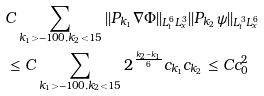Convert formula to latex. <formula><loc_0><loc_0><loc_500><loc_500>& C \sum _ { k _ { 1 } > - 1 0 0 , k _ { 2 } < 1 5 } | | P _ { k _ { 1 } } \nabla \Phi | | _ { L _ { t } ^ { 6 } L _ { x } ^ { 3 } } | | P _ { k _ { 2 } } \psi | | _ { L _ { t } ^ { 3 } L _ { x } ^ { 6 } } \\ & \leq C \sum _ { k _ { 1 } > - 1 0 0 , k _ { 2 } < 1 5 } 2 ^ { \frac { k _ { 2 } - k _ { 1 } } { 6 } } c _ { k _ { 1 } } c _ { k _ { 2 } } \leq C c _ { 0 } ^ { 2 } \\</formula> 